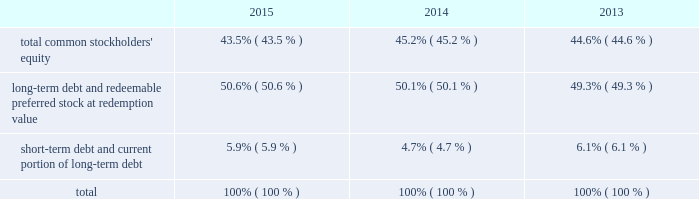The facility is considered 201cdebt 201d for purposes of a support agreement between american water and awcc , which serves as a functional equivalent of a guarantee by american water of awcc 2019s payment obligations under the credit facility .
Also , the company acquired an additional revolving line of credit as part of its keystone acquisition .
The total commitment under this credit facility was $ 16 million of which $ 2 million was outstanding as of december 31 , 2015 .
The table summarizes information regarding the company 2019s aggregate credit facility commitments , letter of credit sub-limits and available funds under those revolving credit facilities , as well as outstanding amounts of commercial paper and outstanding borrowings under the respective facilities as of december 31 , 2015 and 2014 : credit facility commitment available credit facility capacity letter of credit sublimit available letter of credit capacity outstanding commercial ( net of discount ) credit line borrowing ( in millions ) december 31 , 2015 .
$ 1266 $ 1182 $ 150 $ 68 $ 626 $ 2 december 31 , 2014 .
$ 1250 $ 1212 $ 150 $ 112 $ 450 $ 2014 the weighted-average interest rate on awcc short-term borrowings for the years ended december 31 , 2015 and 2014 was approximately 0.49% ( 0.49 % ) and 0.31% ( 0.31 % ) , respectively .
Interest accrues on the keystone revolving line of credit daily at a rate per annum equal to 2.75% ( 2.75 % ) above the greater of the one month or one day libor .
Capital structure the table indicates the percentage of our capitalization represented by the components of our capital structure as of december 31: .
The changes in the capital structure between periods were mainly attributable to changes in outstanding commercial paper balances .
Debt covenants our debt agreements contain financial and non-financial covenants .
To the extent that we are not in compliance with these covenants such an event may create an event of default under the debt agreement and we or our subsidiaries may be restricted in our ability to pay dividends , issue new debt or access our revolving credit facility .
For two of our smaller operating companies , we have informed our counterparties that we will provide only unaudited financial information at the subsidiary level , which resulted in technical non-compliance with certain of their reporting requirements under debt agreements with respect to $ 8 million of outstanding debt .
We do not believe this event will materially impact us .
Our long-term debt indentures contain a number of covenants that , among other things , limit the company from issuing debt secured by the company 2019s assets , subject to certain exceptions .
Our failure to comply with any of these covenants could accelerate repayment obligations .
Certain long-term notes and the revolving credit facility require us to maintain a ratio of consolidated debt to consolidated capitalization ( as defined in the relevant documents ) of not more than 0.70 to 1.00 .
On december 31 , 2015 , our ratio was 0.56 to 1.00 and therefore we were in compliance with the covenant. .
What was the debt to equity ratio in 2015? 
Rationale: the debt to equity is the division of the total debt by the equity
Computations: (50.6 / 5.9)
Answer: 8.57627. 